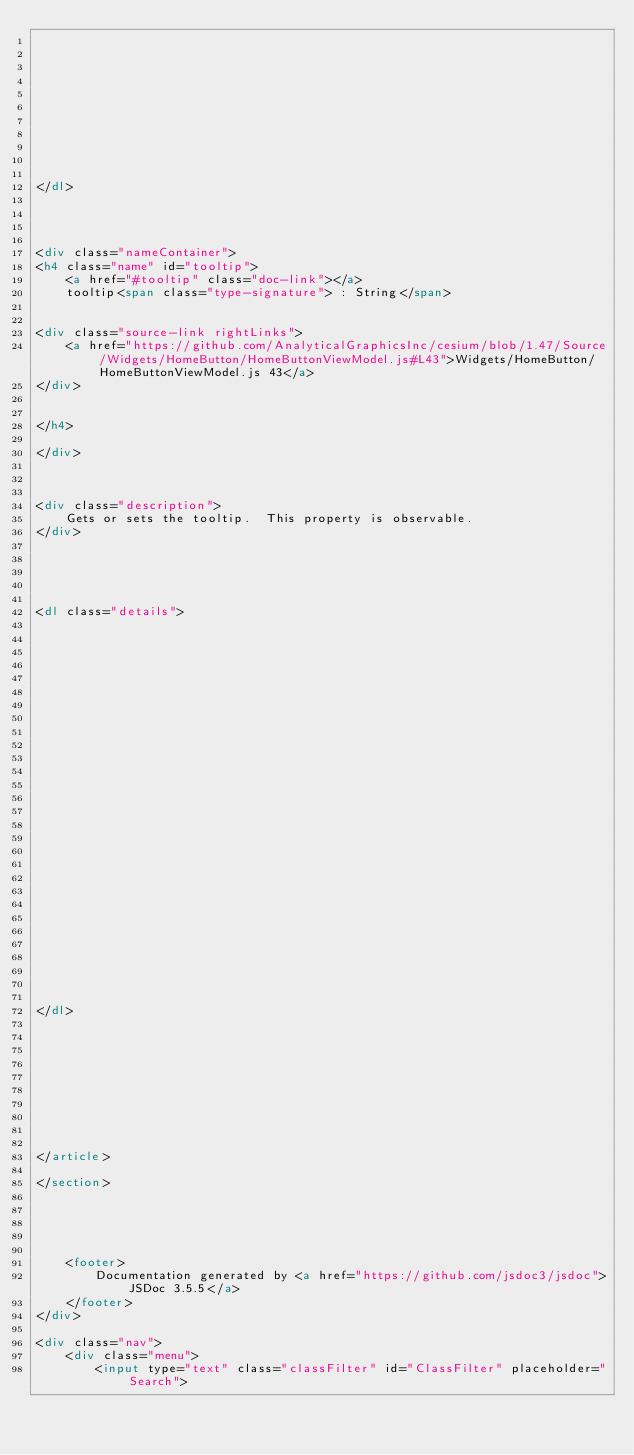Convert code to text. <code><loc_0><loc_0><loc_500><loc_500><_HTML_>    

    

    

    

    

    
</dl>


        
            
<div class="nameContainer">
<h4 class="name" id="tooltip">
    <a href="#tooltip" class="doc-link"></a>
    tooltip<span class="type-signature"> : String</span>
    

<div class="source-link rightLinks">
    <a href="https://github.com/AnalyticalGraphicsInc/cesium/blob/1.47/Source/Widgets/HomeButton/HomeButtonViewModel.js#L43">Widgets/HomeButton/HomeButtonViewModel.js 43</a>
</div>


</h4>

</div>



<div class="description">
    Gets or sets the tooltip.  This property is observable.
</div>





<dl class="details">


    

    

    

    

    

    

    

    

    

    

    

    

    

    
</dl>


        
    

    

    

    
</article>

</section>





    <footer>
        Documentation generated by <a href="https://github.com/jsdoc3/jsdoc">JSDoc 3.5.5</a>
    </footer>
</div>

<div class="nav">
    <div class="menu">
        <input type="text" class="classFilter" id="ClassFilter" placeholder="Search"></code> 